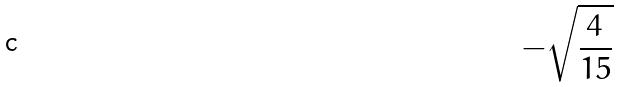Convert formula to latex. <formula><loc_0><loc_0><loc_500><loc_500>- \sqrt { \frac { 4 } { 1 5 } }</formula> 